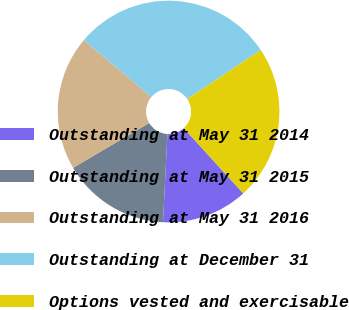Convert chart to OTSL. <chart><loc_0><loc_0><loc_500><loc_500><pie_chart><fcel>Outstanding at May 31 2014<fcel>Outstanding at May 31 2015<fcel>Outstanding at May 31 2016<fcel>Outstanding at December 31<fcel>Options vested and exercisable<nl><fcel>12.57%<fcel>15.72%<fcel>19.63%<fcel>29.49%<fcel>22.59%<nl></chart> 